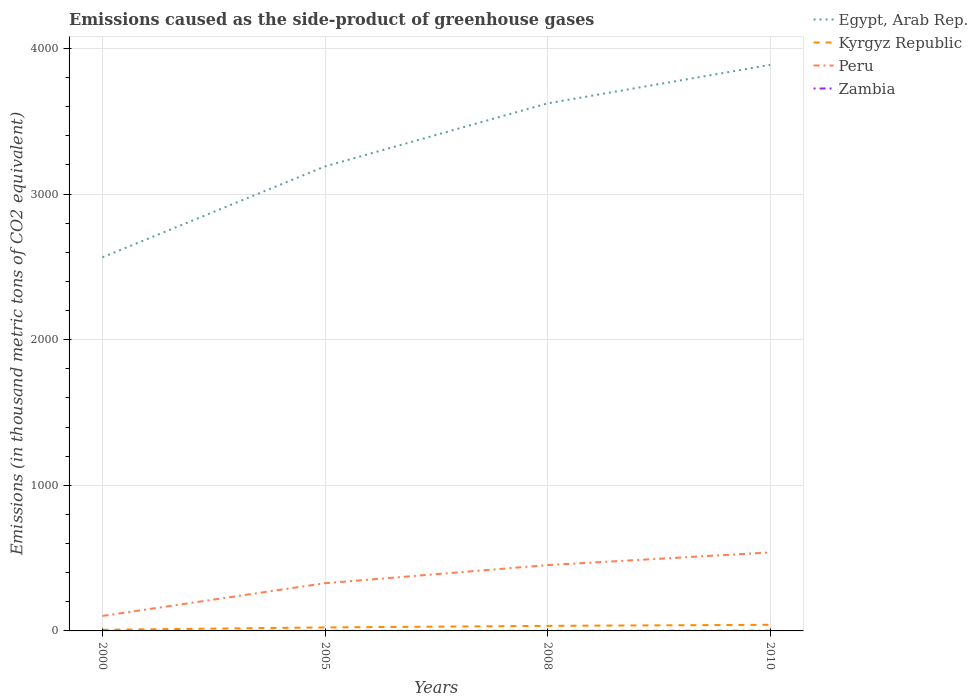How many different coloured lines are there?
Offer a very short reply. 4. Is the number of lines equal to the number of legend labels?
Provide a succinct answer. Yes. Across all years, what is the maximum emissions caused as the side-product of greenhouse gases in Kyrgyz Republic?
Give a very brief answer. 7.9. What is the total emissions caused as the side-product of greenhouse gases in Egypt, Arab Rep. in the graph?
Your answer should be compact. -697.2. What is the difference between the highest and the second highest emissions caused as the side-product of greenhouse gases in Peru?
Offer a very short reply. 435.9. Is the emissions caused as the side-product of greenhouse gases in Egypt, Arab Rep. strictly greater than the emissions caused as the side-product of greenhouse gases in Zambia over the years?
Provide a succinct answer. No. Are the values on the major ticks of Y-axis written in scientific E-notation?
Keep it short and to the point. No. Does the graph contain any zero values?
Give a very brief answer. No. Where does the legend appear in the graph?
Give a very brief answer. Top right. How many legend labels are there?
Your response must be concise. 4. How are the legend labels stacked?
Keep it short and to the point. Vertical. What is the title of the graph?
Provide a short and direct response. Emissions caused as the side-product of greenhouse gases. Does "Liechtenstein" appear as one of the legend labels in the graph?
Give a very brief answer. No. What is the label or title of the Y-axis?
Your response must be concise. Emissions (in thousand metric tons of CO2 equivalent). What is the Emissions (in thousand metric tons of CO2 equivalent) of Egypt, Arab Rep. in 2000?
Your answer should be very brief. 2565.6. What is the Emissions (in thousand metric tons of CO2 equivalent) of Kyrgyz Republic in 2000?
Give a very brief answer. 7.9. What is the Emissions (in thousand metric tons of CO2 equivalent) in Peru in 2000?
Your answer should be compact. 103.1. What is the Emissions (in thousand metric tons of CO2 equivalent) of Zambia in 2000?
Offer a very short reply. 0.1. What is the Emissions (in thousand metric tons of CO2 equivalent) in Egypt, Arab Rep. in 2005?
Provide a succinct answer. 3189.8. What is the Emissions (in thousand metric tons of CO2 equivalent) of Peru in 2005?
Ensure brevity in your answer.  327.6. What is the Emissions (in thousand metric tons of CO2 equivalent) of Egypt, Arab Rep. in 2008?
Make the answer very short. 3622.8. What is the Emissions (in thousand metric tons of CO2 equivalent) in Kyrgyz Republic in 2008?
Offer a terse response. 34.8. What is the Emissions (in thousand metric tons of CO2 equivalent) in Peru in 2008?
Make the answer very short. 452. What is the Emissions (in thousand metric tons of CO2 equivalent) of Egypt, Arab Rep. in 2010?
Give a very brief answer. 3887. What is the Emissions (in thousand metric tons of CO2 equivalent) of Peru in 2010?
Give a very brief answer. 539. What is the Emissions (in thousand metric tons of CO2 equivalent) of Zambia in 2010?
Ensure brevity in your answer.  1. Across all years, what is the maximum Emissions (in thousand metric tons of CO2 equivalent) of Egypt, Arab Rep.?
Offer a very short reply. 3887. Across all years, what is the maximum Emissions (in thousand metric tons of CO2 equivalent) of Kyrgyz Republic?
Your answer should be compact. 42. Across all years, what is the maximum Emissions (in thousand metric tons of CO2 equivalent) in Peru?
Provide a short and direct response. 539. Across all years, what is the minimum Emissions (in thousand metric tons of CO2 equivalent) in Egypt, Arab Rep.?
Offer a very short reply. 2565.6. Across all years, what is the minimum Emissions (in thousand metric tons of CO2 equivalent) in Peru?
Your response must be concise. 103.1. What is the total Emissions (in thousand metric tons of CO2 equivalent) in Egypt, Arab Rep. in the graph?
Make the answer very short. 1.33e+04. What is the total Emissions (in thousand metric tons of CO2 equivalent) of Kyrgyz Republic in the graph?
Ensure brevity in your answer.  108.7. What is the total Emissions (in thousand metric tons of CO2 equivalent) of Peru in the graph?
Your answer should be compact. 1421.7. What is the total Emissions (in thousand metric tons of CO2 equivalent) in Zambia in the graph?
Ensure brevity in your answer.  2. What is the difference between the Emissions (in thousand metric tons of CO2 equivalent) in Egypt, Arab Rep. in 2000 and that in 2005?
Provide a short and direct response. -624.2. What is the difference between the Emissions (in thousand metric tons of CO2 equivalent) of Kyrgyz Republic in 2000 and that in 2005?
Your answer should be very brief. -16.1. What is the difference between the Emissions (in thousand metric tons of CO2 equivalent) in Peru in 2000 and that in 2005?
Your answer should be compact. -224.5. What is the difference between the Emissions (in thousand metric tons of CO2 equivalent) of Egypt, Arab Rep. in 2000 and that in 2008?
Make the answer very short. -1057.2. What is the difference between the Emissions (in thousand metric tons of CO2 equivalent) of Kyrgyz Republic in 2000 and that in 2008?
Ensure brevity in your answer.  -26.9. What is the difference between the Emissions (in thousand metric tons of CO2 equivalent) of Peru in 2000 and that in 2008?
Provide a short and direct response. -348.9. What is the difference between the Emissions (in thousand metric tons of CO2 equivalent) in Zambia in 2000 and that in 2008?
Your answer should be compact. -0.4. What is the difference between the Emissions (in thousand metric tons of CO2 equivalent) of Egypt, Arab Rep. in 2000 and that in 2010?
Your answer should be very brief. -1321.4. What is the difference between the Emissions (in thousand metric tons of CO2 equivalent) of Kyrgyz Republic in 2000 and that in 2010?
Your answer should be very brief. -34.1. What is the difference between the Emissions (in thousand metric tons of CO2 equivalent) of Peru in 2000 and that in 2010?
Your response must be concise. -435.9. What is the difference between the Emissions (in thousand metric tons of CO2 equivalent) in Egypt, Arab Rep. in 2005 and that in 2008?
Your response must be concise. -433. What is the difference between the Emissions (in thousand metric tons of CO2 equivalent) of Kyrgyz Republic in 2005 and that in 2008?
Give a very brief answer. -10.8. What is the difference between the Emissions (in thousand metric tons of CO2 equivalent) of Peru in 2005 and that in 2008?
Provide a succinct answer. -124.4. What is the difference between the Emissions (in thousand metric tons of CO2 equivalent) in Egypt, Arab Rep. in 2005 and that in 2010?
Your answer should be very brief. -697.2. What is the difference between the Emissions (in thousand metric tons of CO2 equivalent) of Peru in 2005 and that in 2010?
Ensure brevity in your answer.  -211.4. What is the difference between the Emissions (in thousand metric tons of CO2 equivalent) of Zambia in 2005 and that in 2010?
Your response must be concise. -0.6. What is the difference between the Emissions (in thousand metric tons of CO2 equivalent) of Egypt, Arab Rep. in 2008 and that in 2010?
Provide a short and direct response. -264.2. What is the difference between the Emissions (in thousand metric tons of CO2 equivalent) in Kyrgyz Republic in 2008 and that in 2010?
Your response must be concise. -7.2. What is the difference between the Emissions (in thousand metric tons of CO2 equivalent) in Peru in 2008 and that in 2010?
Give a very brief answer. -87. What is the difference between the Emissions (in thousand metric tons of CO2 equivalent) in Egypt, Arab Rep. in 2000 and the Emissions (in thousand metric tons of CO2 equivalent) in Kyrgyz Republic in 2005?
Offer a very short reply. 2541.6. What is the difference between the Emissions (in thousand metric tons of CO2 equivalent) of Egypt, Arab Rep. in 2000 and the Emissions (in thousand metric tons of CO2 equivalent) of Peru in 2005?
Provide a succinct answer. 2238. What is the difference between the Emissions (in thousand metric tons of CO2 equivalent) of Egypt, Arab Rep. in 2000 and the Emissions (in thousand metric tons of CO2 equivalent) of Zambia in 2005?
Give a very brief answer. 2565.2. What is the difference between the Emissions (in thousand metric tons of CO2 equivalent) in Kyrgyz Republic in 2000 and the Emissions (in thousand metric tons of CO2 equivalent) in Peru in 2005?
Ensure brevity in your answer.  -319.7. What is the difference between the Emissions (in thousand metric tons of CO2 equivalent) of Peru in 2000 and the Emissions (in thousand metric tons of CO2 equivalent) of Zambia in 2005?
Ensure brevity in your answer.  102.7. What is the difference between the Emissions (in thousand metric tons of CO2 equivalent) of Egypt, Arab Rep. in 2000 and the Emissions (in thousand metric tons of CO2 equivalent) of Kyrgyz Republic in 2008?
Give a very brief answer. 2530.8. What is the difference between the Emissions (in thousand metric tons of CO2 equivalent) of Egypt, Arab Rep. in 2000 and the Emissions (in thousand metric tons of CO2 equivalent) of Peru in 2008?
Your answer should be compact. 2113.6. What is the difference between the Emissions (in thousand metric tons of CO2 equivalent) of Egypt, Arab Rep. in 2000 and the Emissions (in thousand metric tons of CO2 equivalent) of Zambia in 2008?
Ensure brevity in your answer.  2565.1. What is the difference between the Emissions (in thousand metric tons of CO2 equivalent) in Kyrgyz Republic in 2000 and the Emissions (in thousand metric tons of CO2 equivalent) in Peru in 2008?
Give a very brief answer. -444.1. What is the difference between the Emissions (in thousand metric tons of CO2 equivalent) in Kyrgyz Republic in 2000 and the Emissions (in thousand metric tons of CO2 equivalent) in Zambia in 2008?
Your response must be concise. 7.4. What is the difference between the Emissions (in thousand metric tons of CO2 equivalent) of Peru in 2000 and the Emissions (in thousand metric tons of CO2 equivalent) of Zambia in 2008?
Provide a succinct answer. 102.6. What is the difference between the Emissions (in thousand metric tons of CO2 equivalent) in Egypt, Arab Rep. in 2000 and the Emissions (in thousand metric tons of CO2 equivalent) in Kyrgyz Republic in 2010?
Make the answer very short. 2523.6. What is the difference between the Emissions (in thousand metric tons of CO2 equivalent) in Egypt, Arab Rep. in 2000 and the Emissions (in thousand metric tons of CO2 equivalent) in Peru in 2010?
Your answer should be very brief. 2026.6. What is the difference between the Emissions (in thousand metric tons of CO2 equivalent) of Egypt, Arab Rep. in 2000 and the Emissions (in thousand metric tons of CO2 equivalent) of Zambia in 2010?
Make the answer very short. 2564.6. What is the difference between the Emissions (in thousand metric tons of CO2 equivalent) of Kyrgyz Republic in 2000 and the Emissions (in thousand metric tons of CO2 equivalent) of Peru in 2010?
Offer a very short reply. -531.1. What is the difference between the Emissions (in thousand metric tons of CO2 equivalent) in Peru in 2000 and the Emissions (in thousand metric tons of CO2 equivalent) in Zambia in 2010?
Make the answer very short. 102.1. What is the difference between the Emissions (in thousand metric tons of CO2 equivalent) in Egypt, Arab Rep. in 2005 and the Emissions (in thousand metric tons of CO2 equivalent) in Kyrgyz Republic in 2008?
Make the answer very short. 3155. What is the difference between the Emissions (in thousand metric tons of CO2 equivalent) of Egypt, Arab Rep. in 2005 and the Emissions (in thousand metric tons of CO2 equivalent) of Peru in 2008?
Ensure brevity in your answer.  2737.8. What is the difference between the Emissions (in thousand metric tons of CO2 equivalent) of Egypt, Arab Rep. in 2005 and the Emissions (in thousand metric tons of CO2 equivalent) of Zambia in 2008?
Give a very brief answer. 3189.3. What is the difference between the Emissions (in thousand metric tons of CO2 equivalent) in Kyrgyz Republic in 2005 and the Emissions (in thousand metric tons of CO2 equivalent) in Peru in 2008?
Offer a terse response. -428. What is the difference between the Emissions (in thousand metric tons of CO2 equivalent) of Kyrgyz Republic in 2005 and the Emissions (in thousand metric tons of CO2 equivalent) of Zambia in 2008?
Provide a short and direct response. 23.5. What is the difference between the Emissions (in thousand metric tons of CO2 equivalent) in Peru in 2005 and the Emissions (in thousand metric tons of CO2 equivalent) in Zambia in 2008?
Your answer should be compact. 327.1. What is the difference between the Emissions (in thousand metric tons of CO2 equivalent) of Egypt, Arab Rep. in 2005 and the Emissions (in thousand metric tons of CO2 equivalent) of Kyrgyz Republic in 2010?
Offer a very short reply. 3147.8. What is the difference between the Emissions (in thousand metric tons of CO2 equivalent) of Egypt, Arab Rep. in 2005 and the Emissions (in thousand metric tons of CO2 equivalent) of Peru in 2010?
Offer a terse response. 2650.8. What is the difference between the Emissions (in thousand metric tons of CO2 equivalent) in Egypt, Arab Rep. in 2005 and the Emissions (in thousand metric tons of CO2 equivalent) in Zambia in 2010?
Provide a succinct answer. 3188.8. What is the difference between the Emissions (in thousand metric tons of CO2 equivalent) in Kyrgyz Republic in 2005 and the Emissions (in thousand metric tons of CO2 equivalent) in Peru in 2010?
Keep it short and to the point. -515. What is the difference between the Emissions (in thousand metric tons of CO2 equivalent) in Kyrgyz Republic in 2005 and the Emissions (in thousand metric tons of CO2 equivalent) in Zambia in 2010?
Your answer should be compact. 23. What is the difference between the Emissions (in thousand metric tons of CO2 equivalent) of Peru in 2005 and the Emissions (in thousand metric tons of CO2 equivalent) of Zambia in 2010?
Your answer should be very brief. 326.6. What is the difference between the Emissions (in thousand metric tons of CO2 equivalent) of Egypt, Arab Rep. in 2008 and the Emissions (in thousand metric tons of CO2 equivalent) of Kyrgyz Republic in 2010?
Offer a terse response. 3580.8. What is the difference between the Emissions (in thousand metric tons of CO2 equivalent) of Egypt, Arab Rep. in 2008 and the Emissions (in thousand metric tons of CO2 equivalent) of Peru in 2010?
Provide a short and direct response. 3083.8. What is the difference between the Emissions (in thousand metric tons of CO2 equivalent) in Egypt, Arab Rep. in 2008 and the Emissions (in thousand metric tons of CO2 equivalent) in Zambia in 2010?
Make the answer very short. 3621.8. What is the difference between the Emissions (in thousand metric tons of CO2 equivalent) of Kyrgyz Republic in 2008 and the Emissions (in thousand metric tons of CO2 equivalent) of Peru in 2010?
Offer a terse response. -504.2. What is the difference between the Emissions (in thousand metric tons of CO2 equivalent) in Kyrgyz Republic in 2008 and the Emissions (in thousand metric tons of CO2 equivalent) in Zambia in 2010?
Make the answer very short. 33.8. What is the difference between the Emissions (in thousand metric tons of CO2 equivalent) of Peru in 2008 and the Emissions (in thousand metric tons of CO2 equivalent) of Zambia in 2010?
Provide a short and direct response. 451. What is the average Emissions (in thousand metric tons of CO2 equivalent) in Egypt, Arab Rep. per year?
Offer a terse response. 3316.3. What is the average Emissions (in thousand metric tons of CO2 equivalent) of Kyrgyz Republic per year?
Your response must be concise. 27.18. What is the average Emissions (in thousand metric tons of CO2 equivalent) in Peru per year?
Offer a very short reply. 355.43. In the year 2000, what is the difference between the Emissions (in thousand metric tons of CO2 equivalent) in Egypt, Arab Rep. and Emissions (in thousand metric tons of CO2 equivalent) in Kyrgyz Republic?
Keep it short and to the point. 2557.7. In the year 2000, what is the difference between the Emissions (in thousand metric tons of CO2 equivalent) of Egypt, Arab Rep. and Emissions (in thousand metric tons of CO2 equivalent) of Peru?
Offer a terse response. 2462.5. In the year 2000, what is the difference between the Emissions (in thousand metric tons of CO2 equivalent) of Egypt, Arab Rep. and Emissions (in thousand metric tons of CO2 equivalent) of Zambia?
Offer a very short reply. 2565.5. In the year 2000, what is the difference between the Emissions (in thousand metric tons of CO2 equivalent) of Kyrgyz Republic and Emissions (in thousand metric tons of CO2 equivalent) of Peru?
Give a very brief answer. -95.2. In the year 2000, what is the difference between the Emissions (in thousand metric tons of CO2 equivalent) of Kyrgyz Republic and Emissions (in thousand metric tons of CO2 equivalent) of Zambia?
Offer a very short reply. 7.8. In the year 2000, what is the difference between the Emissions (in thousand metric tons of CO2 equivalent) of Peru and Emissions (in thousand metric tons of CO2 equivalent) of Zambia?
Keep it short and to the point. 103. In the year 2005, what is the difference between the Emissions (in thousand metric tons of CO2 equivalent) of Egypt, Arab Rep. and Emissions (in thousand metric tons of CO2 equivalent) of Kyrgyz Republic?
Your answer should be very brief. 3165.8. In the year 2005, what is the difference between the Emissions (in thousand metric tons of CO2 equivalent) in Egypt, Arab Rep. and Emissions (in thousand metric tons of CO2 equivalent) in Peru?
Ensure brevity in your answer.  2862.2. In the year 2005, what is the difference between the Emissions (in thousand metric tons of CO2 equivalent) in Egypt, Arab Rep. and Emissions (in thousand metric tons of CO2 equivalent) in Zambia?
Your answer should be very brief. 3189.4. In the year 2005, what is the difference between the Emissions (in thousand metric tons of CO2 equivalent) in Kyrgyz Republic and Emissions (in thousand metric tons of CO2 equivalent) in Peru?
Keep it short and to the point. -303.6. In the year 2005, what is the difference between the Emissions (in thousand metric tons of CO2 equivalent) in Kyrgyz Republic and Emissions (in thousand metric tons of CO2 equivalent) in Zambia?
Make the answer very short. 23.6. In the year 2005, what is the difference between the Emissions (in thousand metric tons of CO2 equivalent) in Peru and Emissions (in thousand metric tons of CO2 equivalent) in Zambia?
Offer a very short reply. 327.2. In the year 2008, what is the difference between the Emissions (in thousand metric tons of CO2 equivalent) in Egypt, Arab Rep. and Emissions (in thousand metric tons of CO2 equivalent) in Kyrgyz Republic?
Provide a short and direct response. 3588. In the year 2008, what is the difference between the Emissions (in thousand metric tons of CO2 equivalent) in Egypt, Arab Rep. and Emissions (in thousand metric tons of CO2 equivalent) in Peru?
Your answer should be very brief. 3170.8. In the year 2008, what is the difference between the Emissions (in thousand metric tons of CO2 equivalent) of Egypt, Arab Rep. and Emissions (in thousand metric tons of CO2 equivalent) of Zambia?
Make the answer very short. 3622.3. In the year 2008, what is the difference between the Emissions (in thousand metric tons of CO2 equivalent) in Kyrgyz Republic and Emissions (in thousand metric tons of CO2 equivalent) in Peru?
Keep it short and to the point. -417.2. In the year 2008, what is the difference between the Emissions (in thousand metric tons of CO2 equivalent) in Kyrgyz Republic and Emissions (in thousand metric tons of CO2 equivalent) in Zambia?
Your response must be concise. 34.3. In the year 2008, what is the difference between the Emissions (in thousand metric tons of CO2 equivalent) of Peru and Emissions (in thousand metric tons of CO2 equivalent) of Zambia?
Keep it short and to the point. 451.5. In the year 2010, what is the difference between the Emissions (in thousand metric tons of CO2 equivalent) in Egypt, Arab Rep. and Emissions (in thousand metric tons of CO2 equivalent) in Kyrgyz Republic?
Your answer should be compact. 3845. In the year 2010, what is the difference between the Emissions (in thousand metric tons of CO2 equivalent) in Egypt, Arab Rep. and Emissions (in thousand metric tons of CO2 equivalent) in Peru?
Your answer should be very brief. 3348. In the year 2010, what is the difference between the Emissions (in thousand metric tons of CO2 equivalent) of Egypt, Arab Rep. and Emissions (in thousand metric tons of CO2 equivalent) of Zambia?
Make the answer very short. 3886. In the year 2010, what is the difference between the Emissions (in thousand metric tons of CO2 equivalent) of Kyrgyz Republic and Emissions (in thousand metric tons of CO2 equivalent) of Peru?
Give a very brief answer. -497. In the year 2010, what is the difference between the Emissions (in thousand metric tons of CO2 equivalent) in Peru and Emissions (in thousand metric tons of CO2 equivalent) in Zambia?
Offer a very short reply. 538. What is the ratio of the Emissions (in thousand metric tons of CO2 equivalent) in Egypt, Arab Rep. in 2000 to that in 2005?
Your response must be concise. 0.8. What is the ratio of the Emissions (in thousand metric tons of CO2 equivalent) of Kyrgyz Republic in 2000 to that in 2005?
Ensure brevity in your answer.  0.33. What is the ratio of the Emissions (in thousand metric tons of CO2 equivalent) of Peru in 2000 to that in 2005?
Your answer should be compact. 0.31. What is the ratio of the Emissions (in thousand metric tons of CO2 equivalent) of Zambia in 2000 to that in 2005?
Make the answer very short. 0.25. What is the ratio of the Emissions (in thousand metric tons of CO2 equivalent) in Egypt, Arab Rep. in 2000 to that in 2008?
Ensure brevity in your answer.  0.71. What is the ratio of the Emissions (in thousand metric tons of CO2 equivalent) of Kyrgyz Republic in 2000 to that in 2008?
Make the answer very short. 0.23. What is the ratio of the Emissions (in thousand metric tons of CO2 equivalent) in Peru in 2000 to that in 2008?
Your answer should be very brief. 0.23. What is the ratio of the Emissions (in thousand metric tons of CO2 equivalent) in Egypt, Arab Rep. in 2000 to that in 2010?
Your response must be concise. 0.66. What is the ratio of the Emissions (in thousand metric tons of CO2 equivalent) in Kyrgyz Republic in 2000 to that in 2010?
Your response must be concise. 0.19. What is the ratio of the Emissions (in thousand metric tons of CO2 equivalent) in Peru in 2000 to that in 2010?
Provide a short and direct response. 0.19. What is the ratio of the Emissions (in thousand metric tons of CO2 equivalent) in Egypt, Arab Rep. in 2005 to that in 2008?
Provide a succinct answer. 0.88. What is the ratio of the Emissions (in thousand metric tons of CO2 equivalent) in Kyrgyz Republic in 2005 to that in 2008?
Your response must be concise. 0.69. What is the ratio of the Emissions (in thousand metric tons of CO2 equivalent) in Peru in 2005 to that in 2008?
Your answer should be compact. 0.72. What is the ratio of the Emissions (in thousand metric tons of CO2 equivalent) of Zambia in 2005 to that in 2008?
Your answer should be very brief. 0.8. What is the ratio of the Emissions (in thousand metric tons of CO2 equivalent) in Egypt, Arab Rep. in 2005 to that in 2010?
Your answer should be compact. 0.82. What is the ratio of the Emissions (in thousand metric tons of CO2 equivalent) of Kyrgyz Republic in 2005 to that in 2010?
Provide a short and direct response. 0.57. What is the ratio of the Emissions (in thousand metric tons of CO2 equivalent) in Peru in 2005 to that in 2010?
Your answer should be very brief. 0.61. What is the ratio of the Emissions (in thousand metric tons of CO2 equivalent) in Egypt, Arab Rep. in 2008 to that in 2010?
Give a very brief answer. 0.93. What is the ratio of the Emissions (in thousand metric tons of CO2 equivalent) in Kyrgyz Republic in 2008 to that in 2010?
Your response must be concise. 0.83. What is the ratio of the Emissions (in thousand metric tons of CO2 equivalent) in Peru in 2008 to that in 2010?
Your answer should be very brief. 0.84. What is the difference between the highest and the second highest Emissions (in thousand metric tons of CO2 equivalent) in Egypt, Arab Rep.?
Offer a terse response. 264.2. What is the difference between the highest and the second highest Emissions (in thousand metric tons of CO2 equivalent) of Peru?
Your answer should be very brief. 87. What is the difference between the highest and the lowest Emissions (in thousand metric tons of CO2 equivalent) in Egypt, Arab Rep.?
Provide a succinct answer. 1321.4. What is the difference between the highest and the lowest Emissions (in thousand metric tons of CO2 equivalent) in Kyrgyz Republic?
Keep it short and to the point. 34.1. What is the difference between the highest and the lowest Emissions (in thousand metric tons of CO2 equivalent) in Peru?
Give a very brief answer. 435.9. 